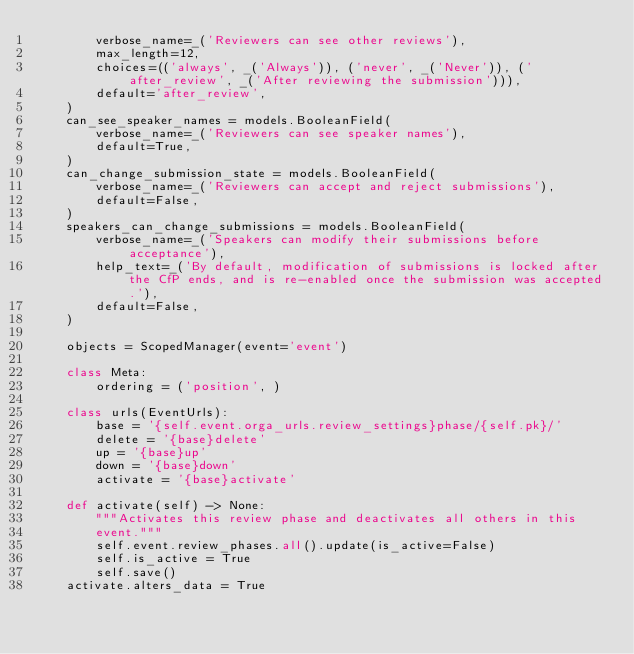Convert code to text. <code><loc_0><loc_0><loc_500><loc_500><_Python_>        verbose_name=_('Reviewers can see other reviews'),
        max_length=12,
        choices=(('always', _('Always')), ('never', _('Never')), ('after_review', _('After reviewing the submission'))),
        default='after_review',
    )
    can_see_speaker_names = models.BooleanField(
        verbose_name=_('Reviewers can see speaker names'),
        default=True,
    )
    can_change_submission_state = models.BooleanField(
        verbose_name=_('Reviewers can accept and reject submissions'),
        default=False,
    )
    speakers_can_change_submissions = models.BooleanField(
        verbose_name=_('Speakers can modify their submissions before acceptance'),
        help_text=_('By default, modification of submissions is locked after the CfP ends, and is re-enabled once the submission was accepted.'),
        default=False,
    )

    objects = ScopedManager(event='event')

    class Meta:
        ordering = ('position', )

    class urls(EventUrls):
        base = '{self.event.orga_urls.review_settings}phase/{self.pk}/'
        delete = '{base}delete'
        up = '{base}up'
        down = '{base}down'
        activate = '{base}activate'

    def activate(self) -> None:
        """Activates this review phase and deactivates all others in this
        event."""
        self.event.review_phases.all().update(is_active=False)
        self.is_active = True
        self.save()
    activate.alters_data = True
</code> 